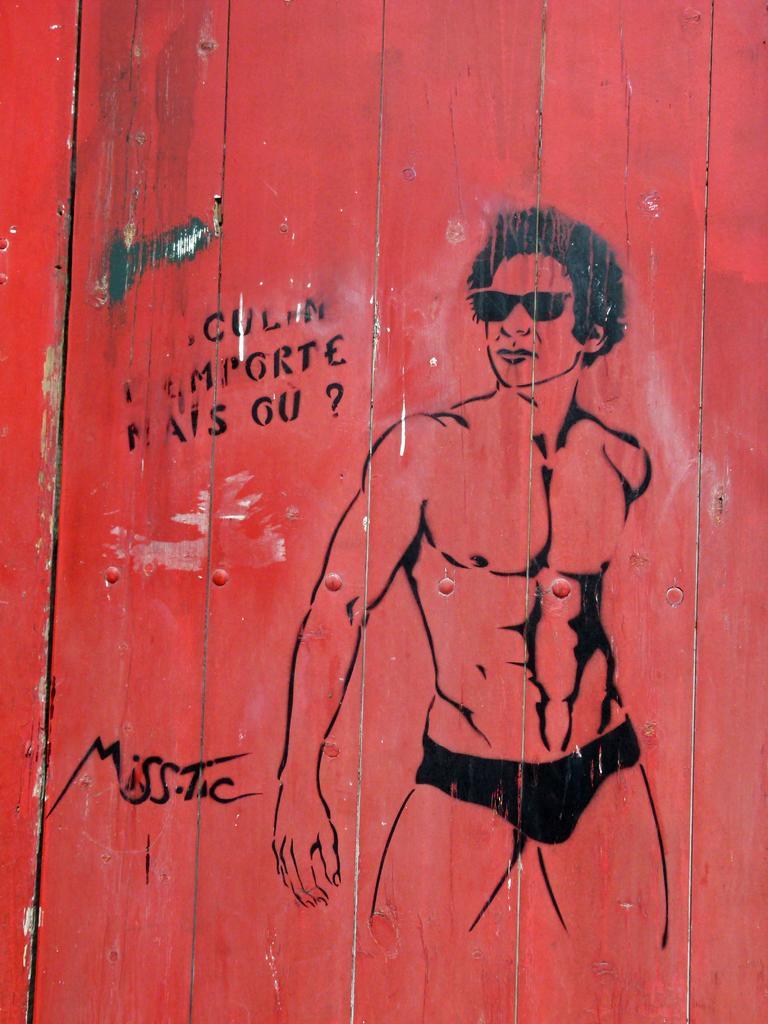In one or two sentences, can you explain what this image depicts? In this image there is a wooden wall, on the wall there is some art and some text. 